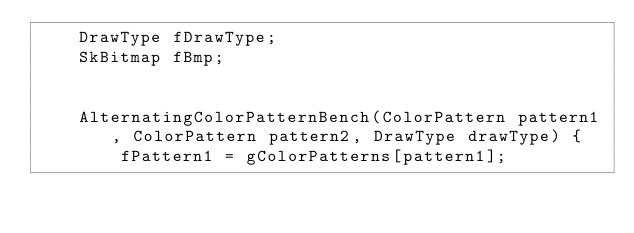<code> <loc_0><loc_0><loc_500><loc_500><_C++_>    DrawType fDrawType;
    SkBitmap fBmp;


    AlternatingColorPatternBench(ColorPattern pattern1, ColorPattern pattern2, DrawType drawType) {
        fPattern1 = gColorPatterns[pattern1];</code> 